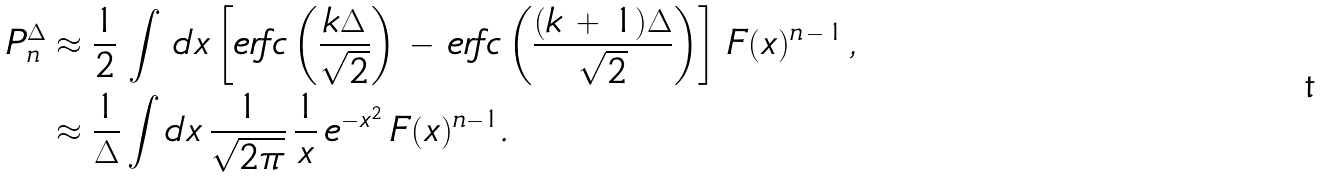<formula> <loc_0><loc_0><loc_500><loc_500>P _ { n } ^ { \Delta } & \approx \frac { 1 } { 2 } \, \int \, d x \left [ e r f c \left ( \frac { k \Delta } { \sqrt { 2 } } \right ) \, - \, e r f c \left ( \frac { ( k \, + \, 1 ) \Delta } { \sqrt { 2 } } \right ) \right ] \, { F ( x ) ^ { n \, - \, 1 } } \, , \\ & \approx \frac { 1 } { \Delta } \int d x \, \frac { 1 } { \sqrt { 2 \pi } } \, \frac { 1 } { x } \, e ^ { - x ^ { 2 } } \, F ( x ) ^ { n - 1 } .</formula> 